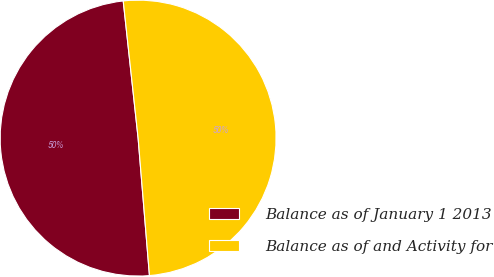Convert chart. <chart><loc_0><loc_0><loc_500><loc_500><pie_chart><fcel>Balance as of January 1 2013<fcel>Balance as of and Activity for<nl><fcel>49.59%<fcel>50.41%<nl></chart> 